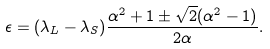<formula> <loc_0><loc_0><loc_500><loc_500>\epsilon = ( \lambda _ { L } - \lambda _ { S } ) \frac { \alpha ^ { 2 } + 1 \pm \sqrt { 2 } ( \alpha ^ { 2 } - 1 ) } { 2 \alpha } .</formula> 